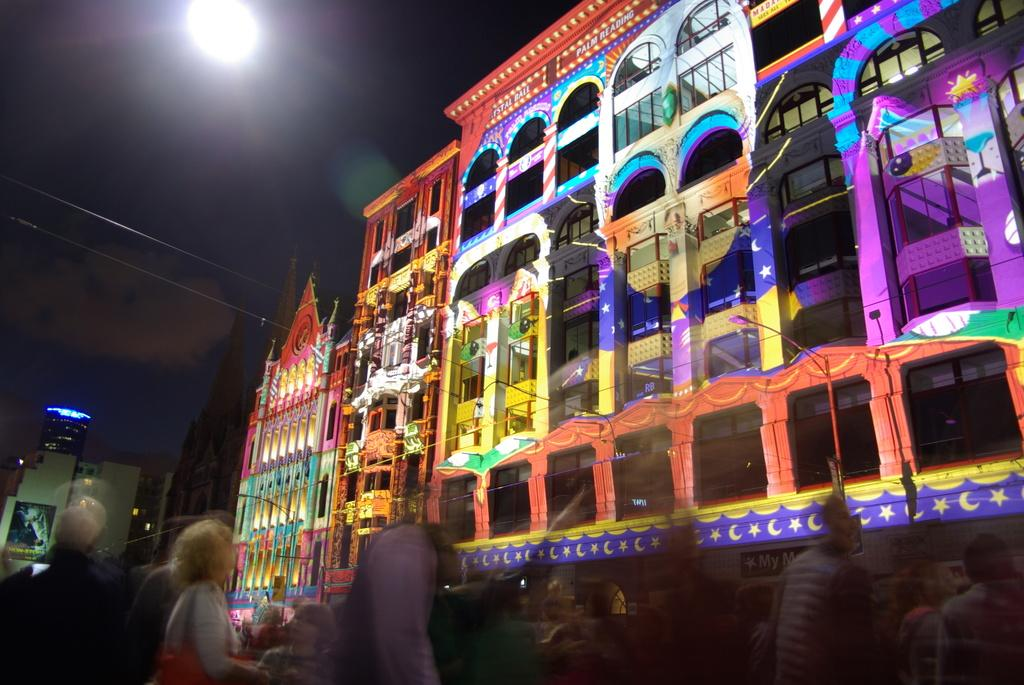What type of structures can be seen in the image? There are buildings in the image. Are there any living beings present in the image? Yes, there are people standing in the image. Can you describe any light source visible in the image? There is a light visible in the image. What type of fruit is being held by the person's aunt in the image? There is no mention of a fruit or an aunt in the image, so this information cannot be determined. 